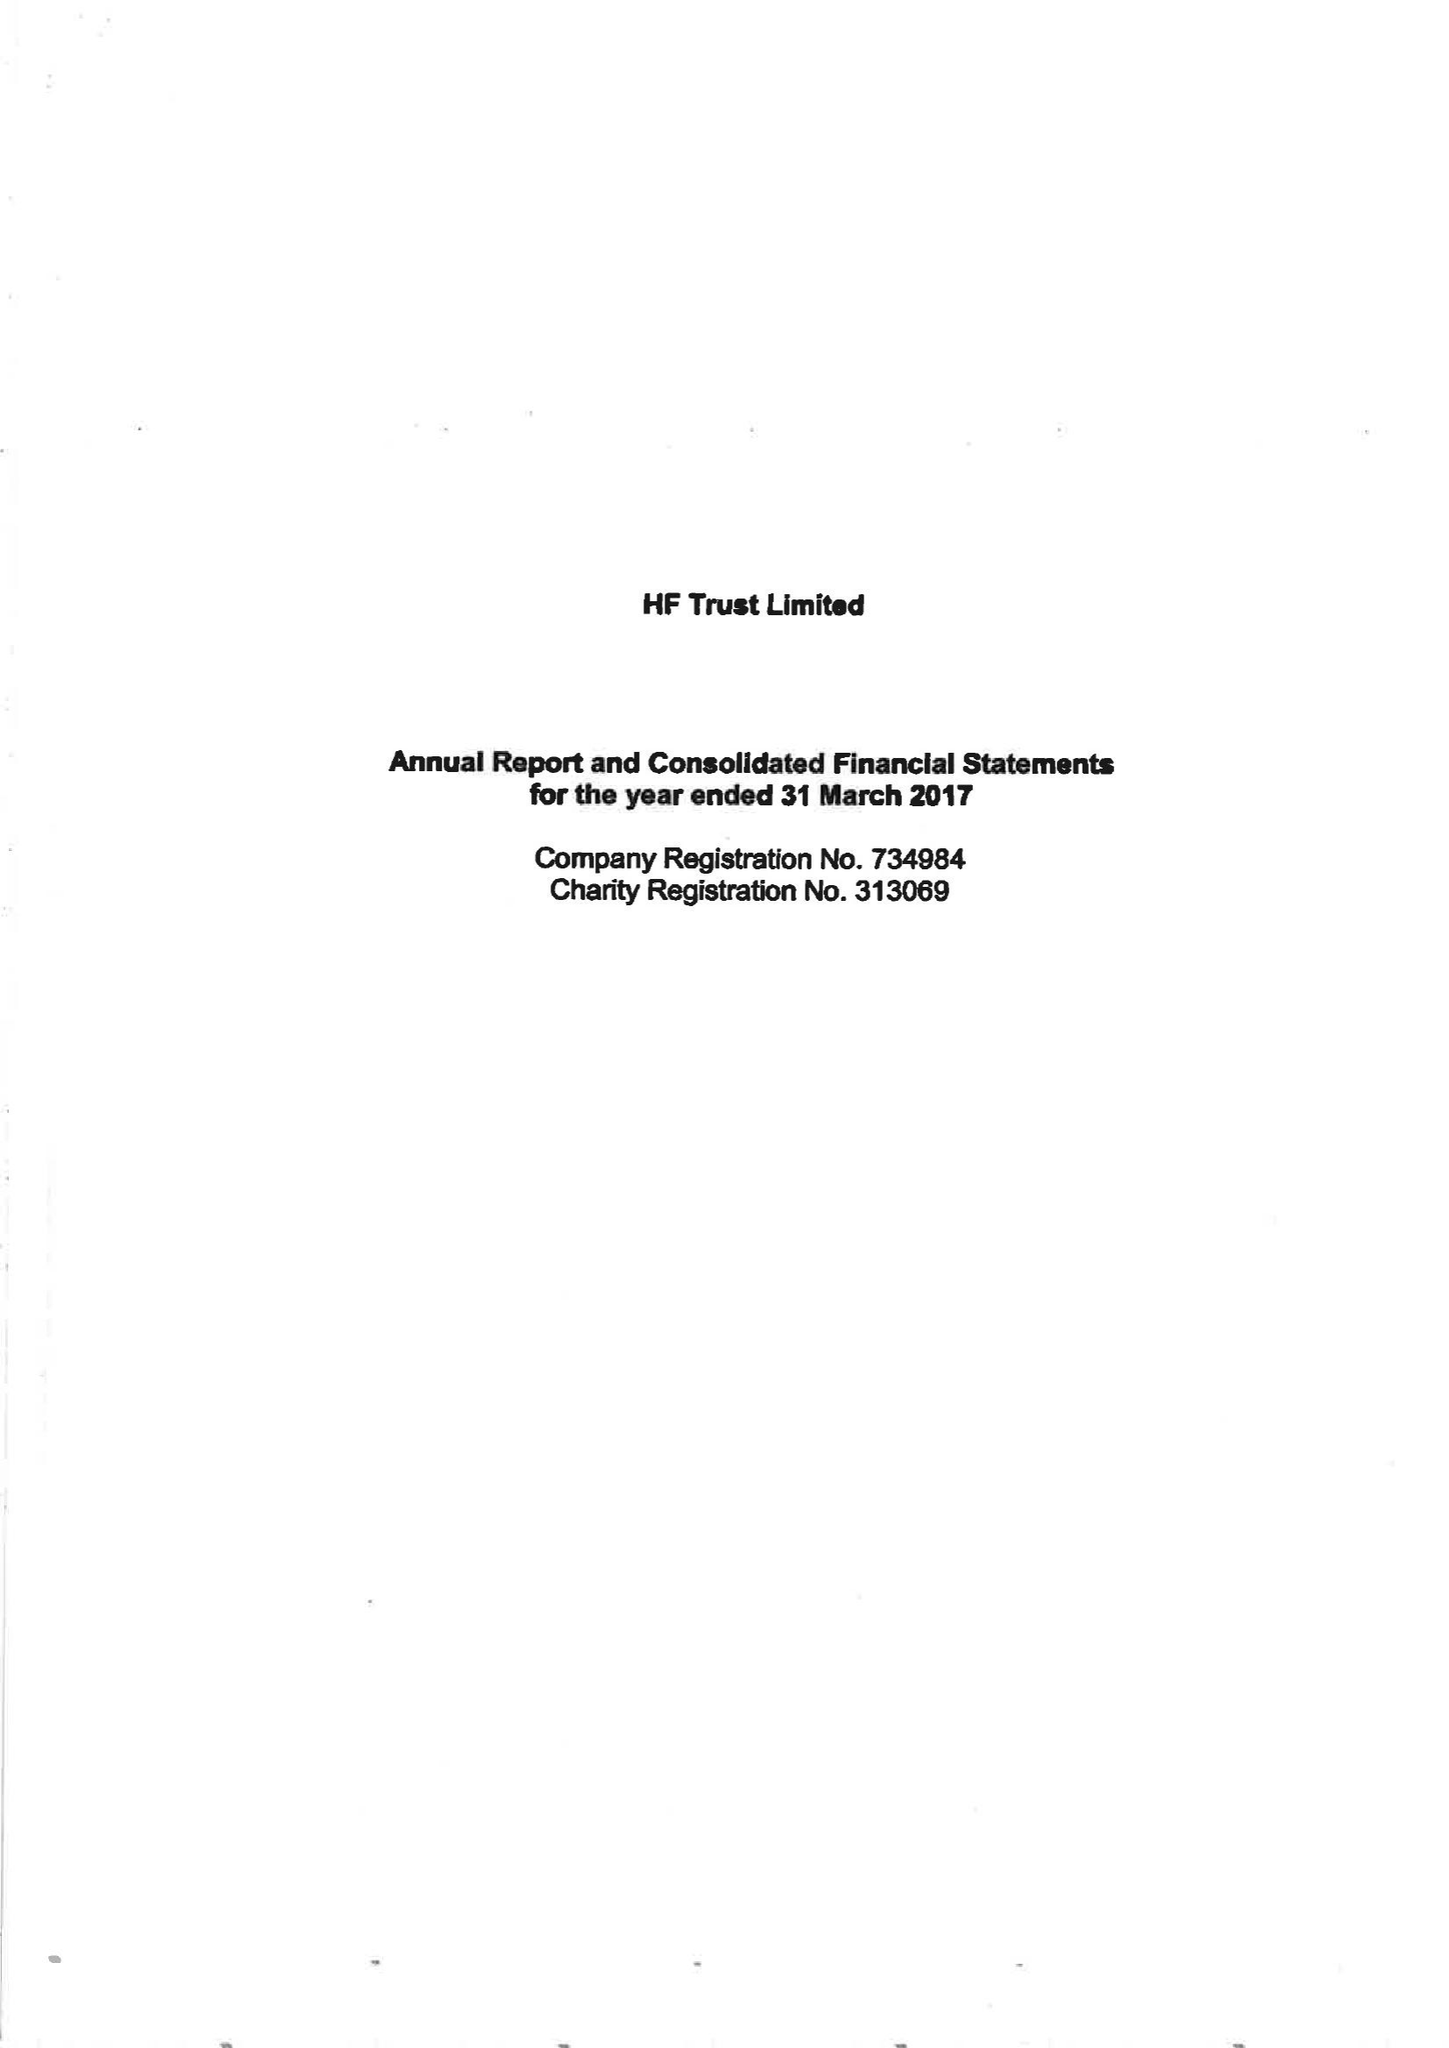What is the value for the address__post_town?
Answer the question using a single word or phrase. BRISTOL 